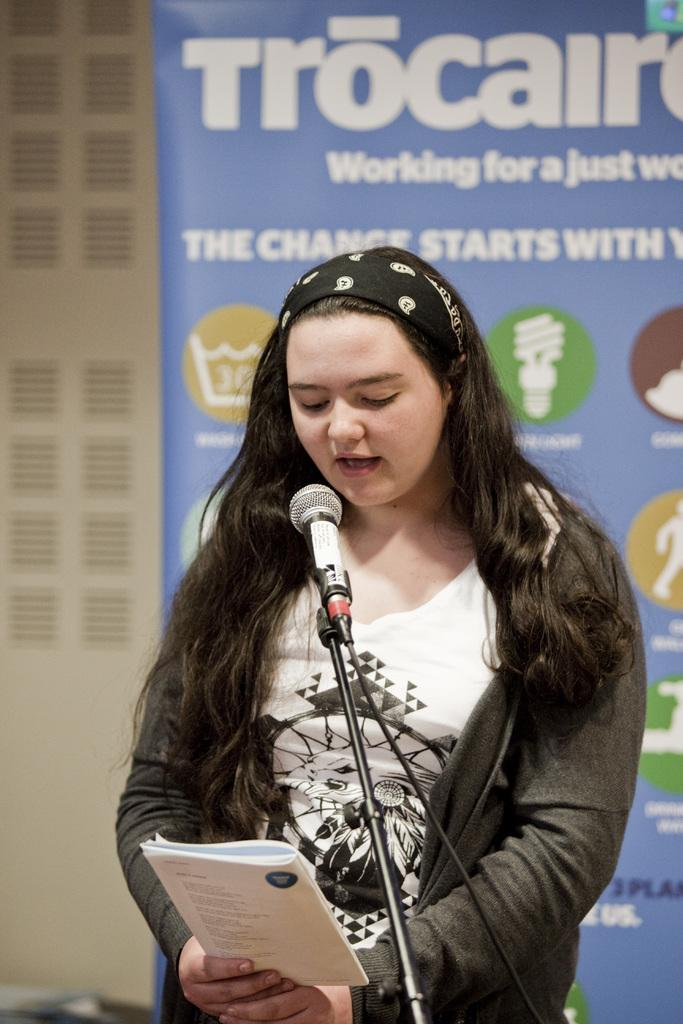Who is the main subject in the image? There is a woman in the image. What is the woman doing in the image? The woman is standing in front of a mic and reading something from a book. What is the woman holding in her hand? The woman is holding a book in her hand. What can be seen behind the woman in the image? There is a banner behind the woman, which has text and images on it. How many mice are crawling on the woman's feet in the image? There are no mice present in the image. What type of servant is standing next to the woman in the image? There is no servant present in the image. 